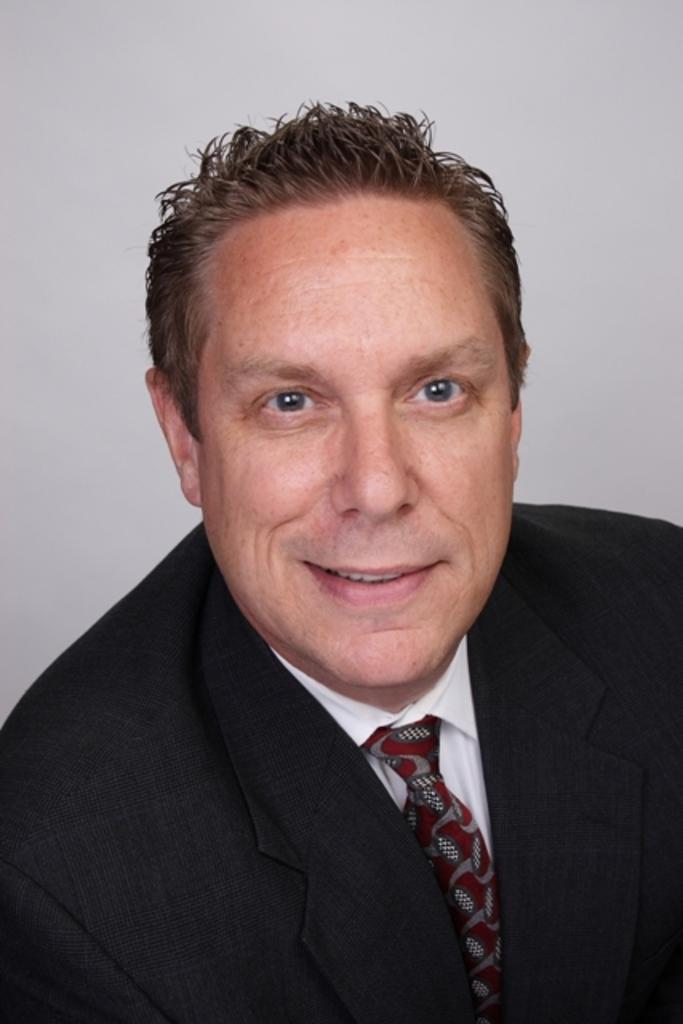Who is present in the image? There is a man in the picture. What is the man's facial expression? The man is smiling. What color is the man's suit? The man is wearing a black suit. What color is the man's tie? The man is wearing a red tie. What color is the man's shirt? The man is wearing a white shirt. What type of butter is the man using to wash his spy equipment in the image? There is no butter, washing, or spy equipment present in the image. 